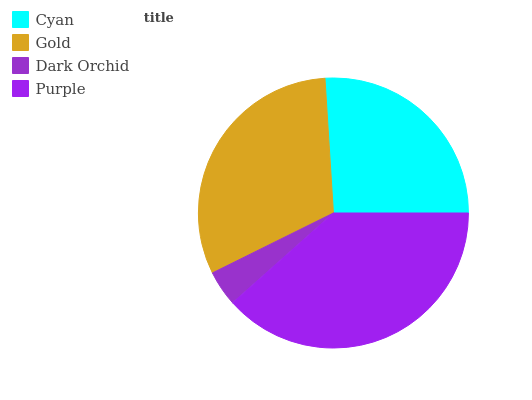Is Dark Orchid the minimum?
Answer yes or no. Yes. Is Purple the maximum?
Answer yes or no. Yes. Is Gold the minimum?
Answer yes or no. No. Is Gold the maximum?
Answer yes or no. No. Is Gold greater than Cyan?
Answer yes or no. Yes. Is Cyan less than Gold?
Answer yes or no. Yes. Is Cyan greater than Gold?
Answer yes or no. No. Is Gold less than Cyan?
Answer yes or no. No. Is Gold the high median?
Answer yes or no. Yes. Is Cyan the low median?
Answer yes or no. Yes. Is Purple the high median?
Answer yes or no. No. Is Purple the low median?
Answer yes or no. No. 